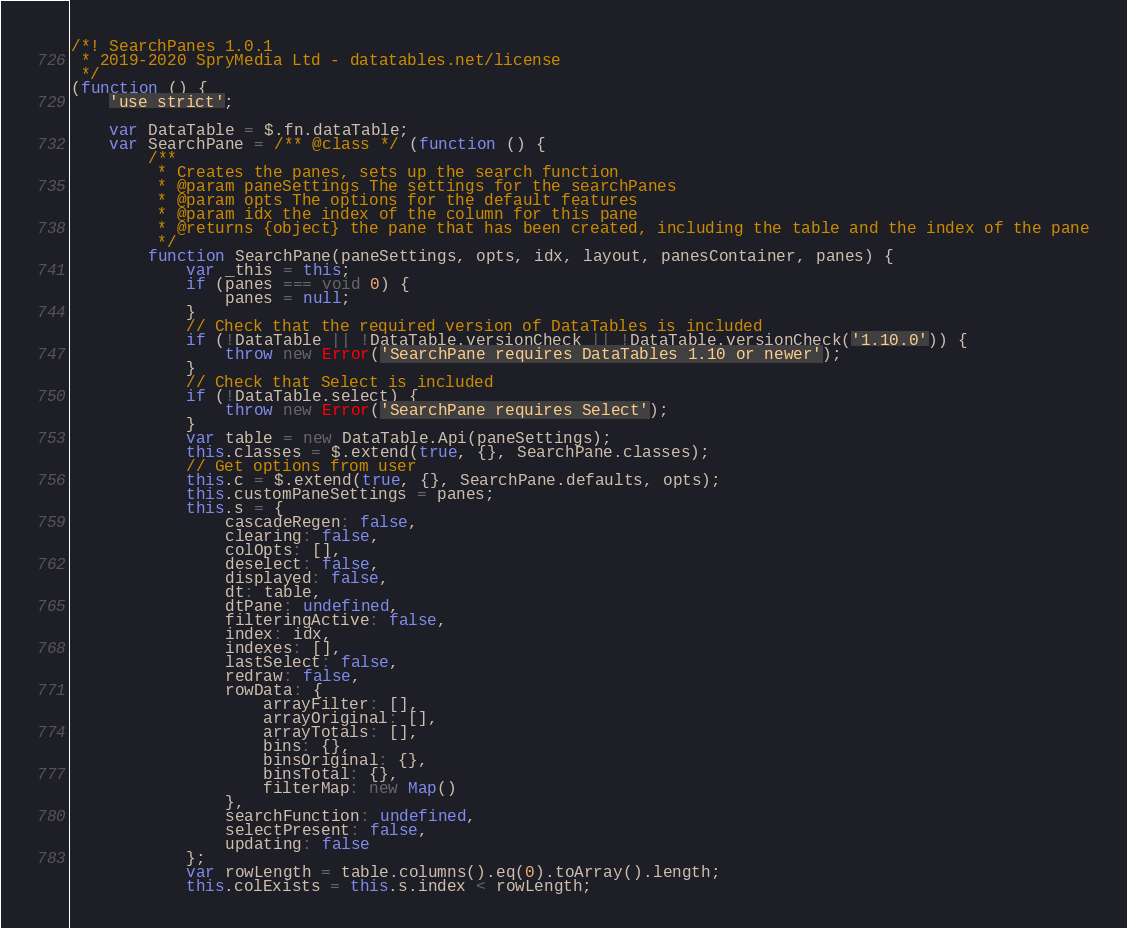Convert code to text. <code><loc_0><loc_0><loc_500><loc_500><_JavaScript_>/*! SearchPanes 1.0.1
 * 2019-2020 SpryMedia Ltd - datatables.net/license
 */
(function () {
    'use strict';

    var DataTable = $.fn.dataTable;
    var SearchPane = /** @class */ (function () {
        /**
         * Creates the panes, sets up the search function
         * @param paneSettings The settings for the searchPanes
         * @param opts The options for the default features
         * @param idx the index of the column for this pane
         * @returns {object} the pane that has been created, including the table and the index of the pane
         */
        function SearchPane(paneSettings, opts, idx, layout, panesContainer, panes) {
            var _this = this;
            if (panes === void 0) {
                panes = null;
            }
            // Check that the required version of DataTables is included
            if (!DataTable || !DataTable.versionCheck || !DataTable.versionCheck('1.10.0')) {
                throw new Error('SearchPane requires DataTables 1.10 or newer');
            }
            // Check that Select is included
            if (!DataTable.select) {
                throw new Error('SearchPane requires Select');
            }
            var table = new DataTable.Api(paneSettings);
            this.classes = $.extend(true, {}, SearchPane.classes);
            // Get options from user
            this.c = $.extend(true, {}, SearchPane.defaults, opts);
            this.customPaneSettings = panes;
            this.s = {
                cascadeRegen: false,
                clearing: false,
                colOpts: [],
                deselect: false,
                displayed: false,
                dt: table,
                dtPane: undefined,
                filteringActive: false,
                index: idx,
                indexes: [],
                lastSelect: false,
                redraw: false,
                rowData: {
                    arrayFilter: [],
                    arrayOriginal: [],
                    arrayTotals: [],
                    bins: {},
                    binsOriginal: {},
                    binsTotal: {},
                    filterMap: new Map()
                },
                searchFunction: undefined,
                selectPresent: false,
                updating: false
            };
            var rowLength = table.columns().eq(0).toArray().length;
            this.colExists = this.s.index < rowLength;</code> 